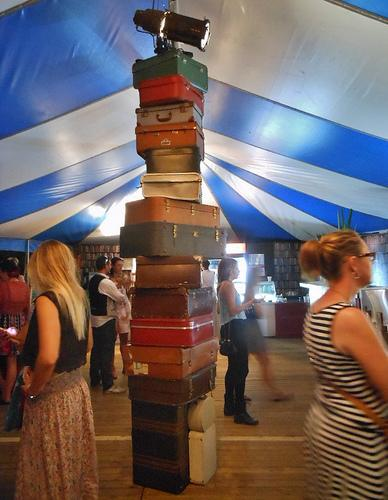Provide a brief account of the woman with her hands on her hips. The woman is light-skinned, has long hair, wears a skirt, and is in a pose with her hands on her hips. Mention three distinct objects observed in the image. A stack of suitcases, woman wearing a striped dress, and blue and white tent over head. Give a brief description of the woman wearing the striped dress. The woman is light skinned, has her hair tied back, wears black and white striped dress, black glasses, and an earring. Mention the type of flooring and an object found on it. The floor is wooden and has a brown purse strap on it. Describe one of the people's clothing in the image. A man is wearing a black vest and black pants with a wooden floor background. Describe the type and color of the tent seen in the image. The tent is blue and white, with a metal pole supporting it. In your own words, describe the immediate surrounding of the woman wearing a striped dress. The woman stands near a stack of suitcases with a light on top, a large light source nearby, and she is by a wooden plank floor. 